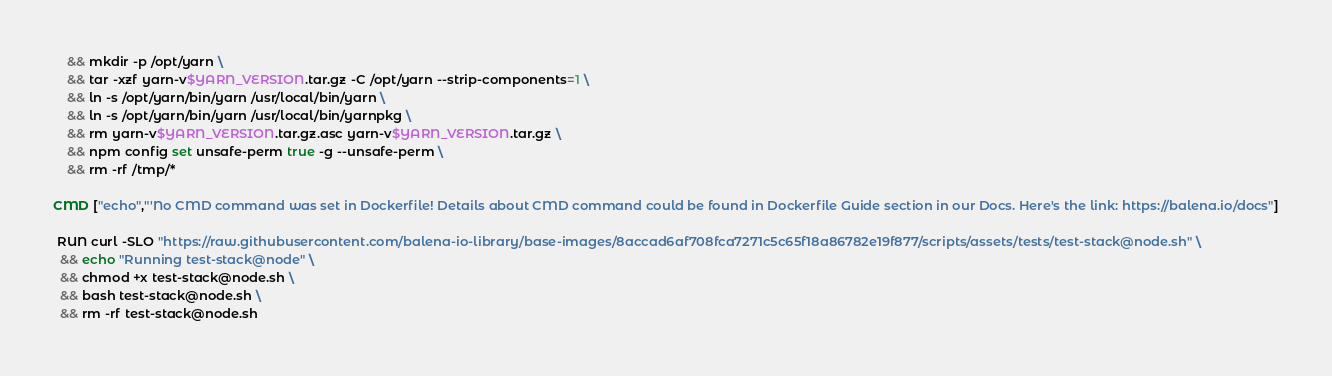Convert code to text. <code><loc_0><loc_0><loc_500><loc_500><_Dockerfile_>	&& mkdir -p /opt/yarn \
	&& tar -xzf yarn-v$YARN_VERSION.tar.gz -C /opt/yarn --strip-components=1 \
	&& ln -s /opt/yarn/bin/yarn /usr/local/bin/yarn \
	&& ln -s /opt/yarn/bin/yarn /usr/local/bin/yarnpkg \
	&& rm yarn-v$YARN_VERSION.tar.gz.asc yarn-v$YARN_VERSION.tar.gz \
	&& npm config set unsafe-perm true -g --unsafe-perm \
	&& rm -rf /tmp/*

CMD ["echo","'No CMD command was set in Dockerfile! Details about CMD command could be found in Dockerfile Guide section in our Docs. Here's the link: https://balena.io/docs"]

 RUN curl -SLO "https://raw.githubusercontent.com/balena-io-library/base-images/8accad6af708fca7271c5c65f18a86782e19f877/scripts/assets/tests/test-stack@node.sh" \
  && echo "Running test-stack@node" \
  && chmod +x test-stack@node.sh \
  && bash test-stack@node.sh \
  && rm -rf test-stack@node.sh 
</code> 